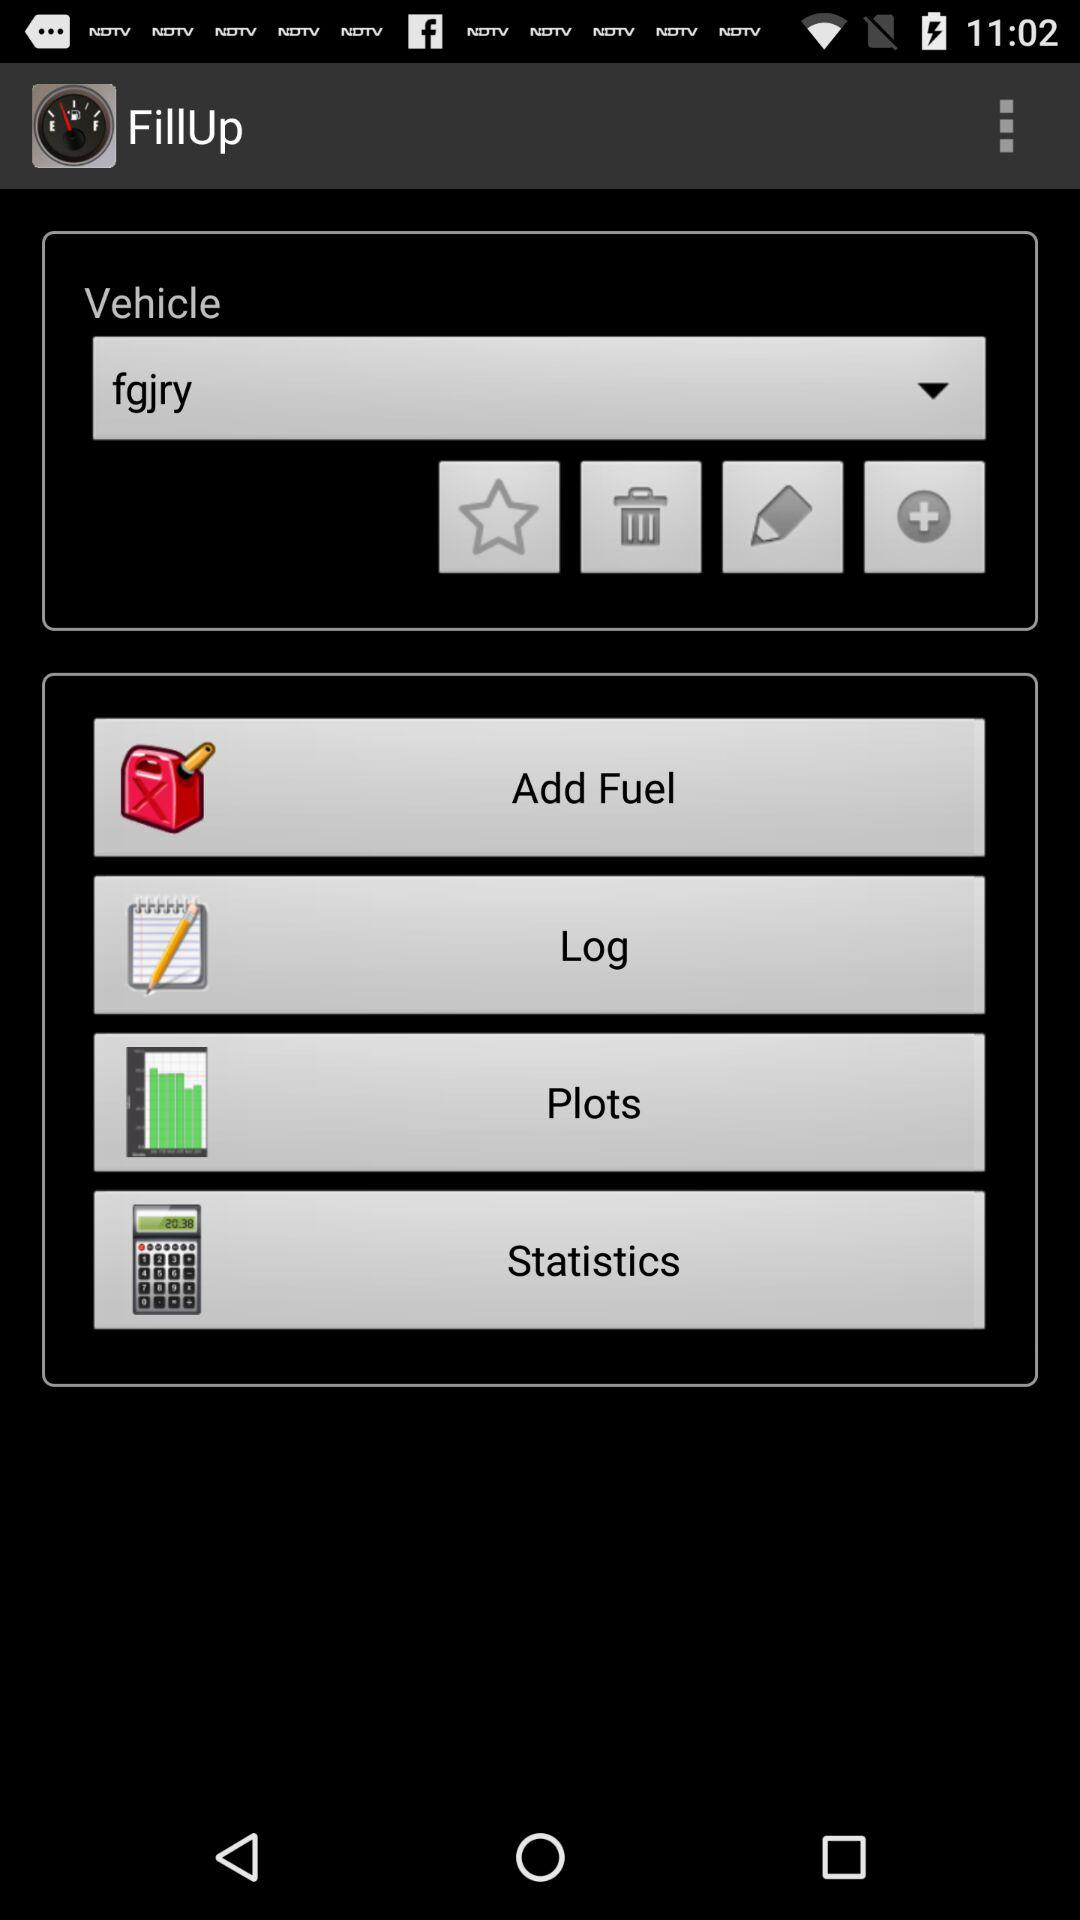What is the application name? The application name is "FillUp". 